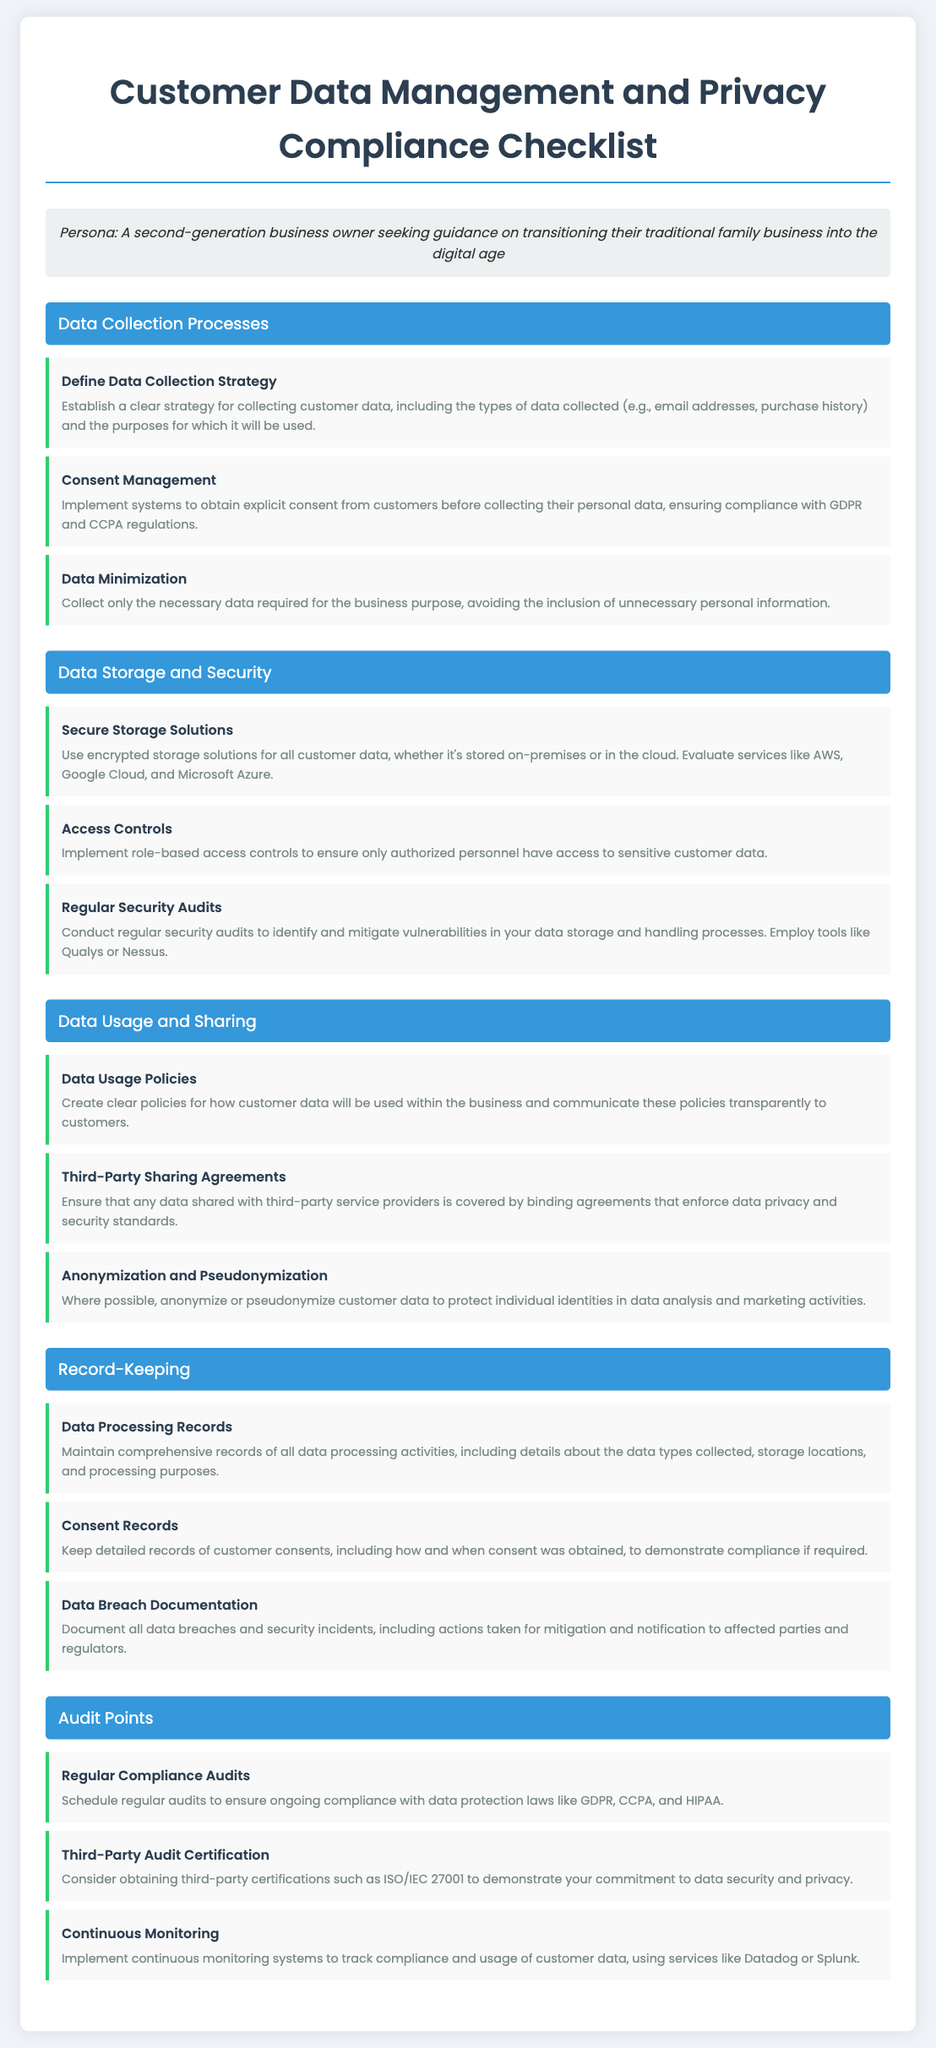what is the title of the document? The title of the document is prominently displayed at the top and is "Customer Data Management and Privacy Compliance Checklist".
Answer: Customer Data Management and Privacy Compliance Checklist how many sections are in the checklist? The document is divided into various sections, each labeled for different aspects of customer data management, totaling five sections: Data Collection Processes, Data Storage and Security, Data Usage and Sharing, Record-Keeping, and Audit Points.
Answer: 5 what is the first item under Data Collection Processes? The first item under the section titled "Data Collection Processes" is the "Define Data Collection Strategy".
Answer: Define Data Collection Strategy which third-party certification is mentioned for data security and privacy? The checklist mentions obtaining "ISO/IEC 27001" as a certification to demonstrate commitment to data security and privacy.
Answer: ISO/IEC 27001 what is the purpose of consent management? The purpose of consent management is stated as implementing systems to obtain explicit consent from customers before collecting their personal data to ensure compliance with regulations.
Answer: Obtain explicit consent how often should compliance audits be scheduled? The document suggests scheduling regular audits to ensure ongoing compliance with data protection laws.
Answer: Regularly what type of data should be collected according to the Data Minimization principle? According to the Data Minimization principle, only the necessary data required for the business purpose should be collected, without unnecessary personal information.
Answer: Necessary data only how are security audits related to data storage? Security audits are related to data storage as they help identify and mitigate vulnerabilities in the data storage and handling processes.
Answer: Identify and mitigate vulnerabilities 